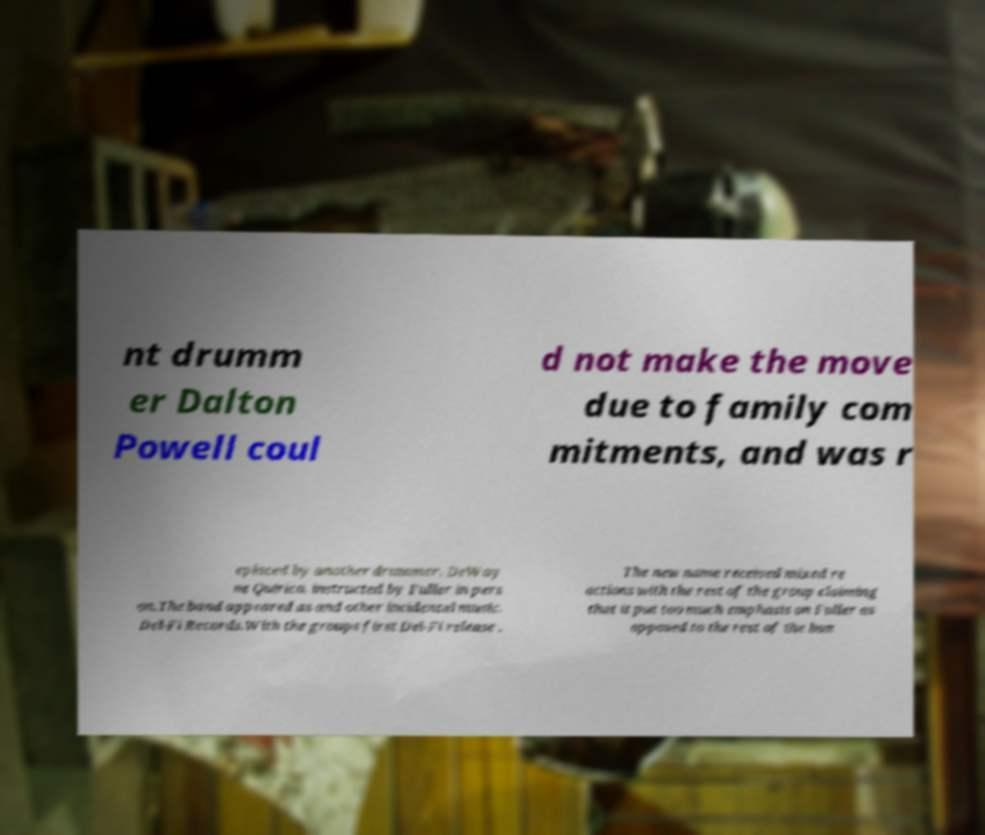For documentation purposes, I need the text within this image transcribed. Could you provide that? nt drumm er Dalton Powell coul d not make the move due to family com mitments, and was r eplaced by another drummer, DeWay ne Quirico, instructed by Fuller in pers on.The band appeared as and other incidental music. Del-Fi Records.With the groups first Del-Fi release . The new name received mixed re actions with the rest of the group claiming that it put too much emphasis on Fuller as opposed to the rest of the ban 